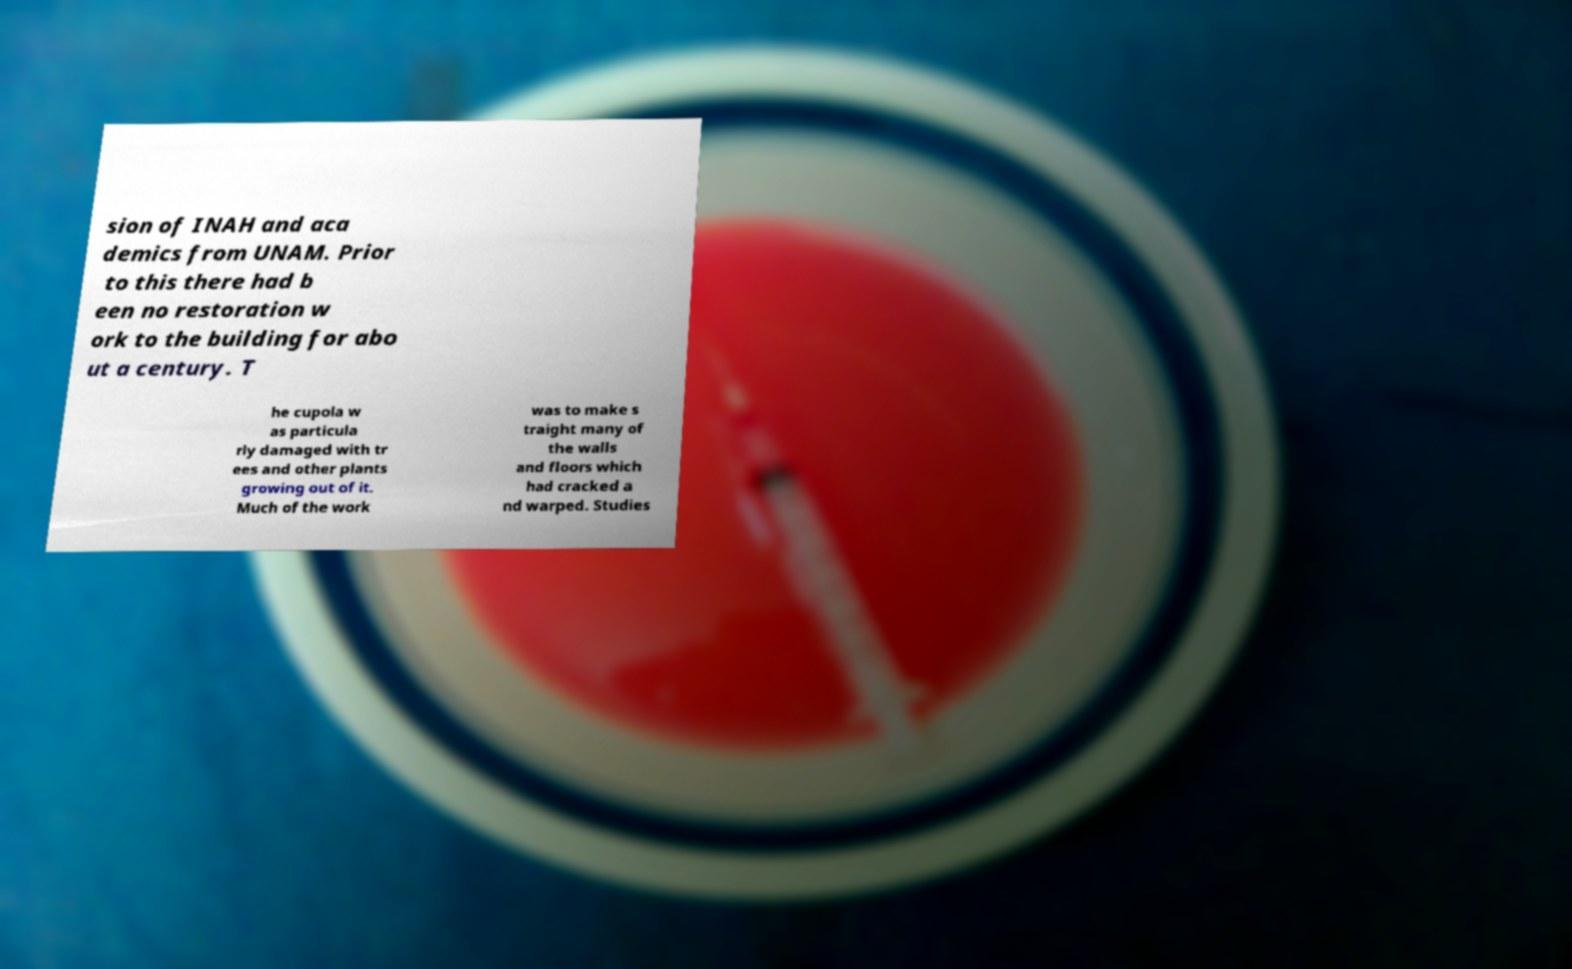I need the written content from this picture converted into text. Can you do that? sion of INAH and aca demics from UNAM. Prior to this there had b een no restoration w ork to the building for abo ut a century. T he cupola w as particula rly damaged with tr ees and other plants growing out of it. Much of the work was to make s traight many of the walls and floors which had cracked a nd warped. Studies 